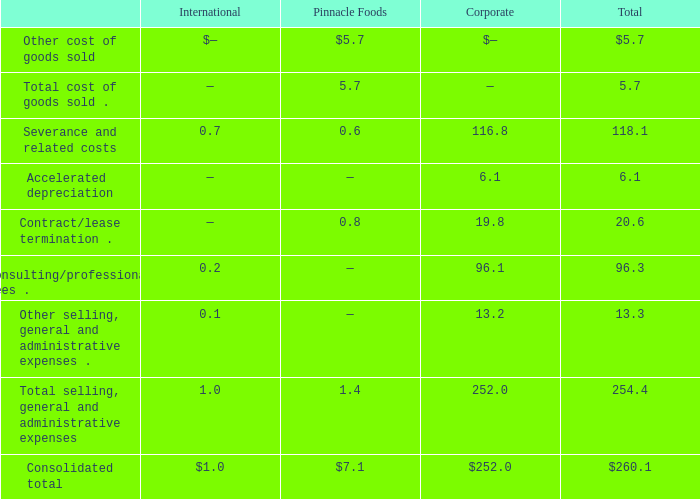Notes to Consolidated Financial Statements - (Continued) Fiscal Years Ended May 26, 2019, May 27, 2018, and May 28, 2017 (columnar dollars in millions except per share amounts) 3. RESTRUCTURING ACTIVITIES
Pinnacle Integration Restructuring Plan
In December 2018, our Board of Directors (the "Board") approved a restructuring and integration plan related to the ongoing integration of the recently acquired operations of Pinnacle (the "Pinnacle Integration Restructuring Plan") for the purpose of achieving significant cost synergies between the companies. We expect to incur material charges for exit and disposal activities under U.S. GAAP. Although we remain unable to make good faith estimates relating to the entire Pinnacle Integration Restructuring Plan, we are reporting on actions initiated through the end of fiscal 2019, including the estimated amounts or range of amounts for each major type of costs expected to be incurred, and the charges that have resulted or will result in cash outflows. We expect to incur up to $360.0 million of operational expenditures ($285.0 million of cash charges and $75.0 million of non-cash charges) as well as $85.0 million of capital expenditures under the Pinnacle Integration Restructuring Plan. We have incurred or expect to incur approximately $260.1 million of charges ($254.0 million of cash charges and $6.1 million of non-cash charges) for actions identified to date under the Pinnacle Integration Restructuring Plan. We expect to incur costs related to the Pinnacle Integration Restructuring Plan over a three-year period.  In December 2018, our Board of Directors (the "Board") approved a restructuring and integration plan related to the ongoing integration of the recently acquired operations of Pinnacle (the "Pinnacle Integration Restructuring Plan") for the purpose of achieving significant cost synergies between the companies. We expect to incur material charges for exit and disposal activities under U.S. GAAP. Although we remain unable to make good faith estimates relating to the entire Pinnacle Integration Restructuring Plan, we are reporting on actions initiated through the end of fiscal 2019, including the estimated amounts or range of amounts for each major type of costs expected to be incurred, and the charges that have resulted or will result in cash outflows. We expect to incur up to $360.0 million of operational expenditures ($285.0 million of cash charges and $75.0 million of non-cash charges) as well as $85.0 million of capital expenditures under the Pinnacle Integration Restructuring Plan. We have incurred or expect to incur approximately $260.1 million of charges ($254.0 million of cash charges and $6.1 million of non-cash charges) for actions identified to date under the Pinnacle Integration Restructuring Plan. We expect to incur costs related to the Pinnacle Integration Restructuring Plan over a three-year period.  In December 2018, our Board of Directors (the "Board") approved a restructuring and integration plan related to the ongoing integration of the recently acquired operations of Pinnacle (the "Pinnacle Integration Restructuring Plan") for the purpose of achieving significant cost synergies between the companies. We expect to incur material charges for exit and disposal activities under U.S. GAAP. Although we remain unable to make good faith estimates relating to the entire Pinnacle Integration Restructuring Plan, we are reporting on actions initiated through the end of fiscal 2019, including the estimated amounts or range of amounts for each major type of costs expected to be incurred, and the charges that have resulted or will result in cash outflows. We expect to incur up to $360.0 million of operational expenditures ($285.0 million of cash charges and $75.0 million of non-cash charges) as well as $85.0 million of capital expenditures under the Pinnacle Integration Restructuring Plan. We have incurred or expect to incur approximately $260.1 million of charges ($254.0 million of cash charges and $6.1 million of non-cash charges) for actions identified to date under the Pinnacle Integration Restructuring Plan. We expect to incur costs related to the Pinnacle Integration Restructuring Plan over a three-year period.
We anticipate that we will recognize the following pre-tax expenses in association with the Pinnacle Integration Restructuring Plan (amounts include charges recognized from plan inception through the end of fiscal 2019):
What did the Board of Directors approve in December 2018?  A restructuring and integration plan related to the ongoing integration of the recently acquired operations of pinnacle (the "pinnacle integration restructuring plan") for the purpose of achieving significant cost synergies between the companies. What are the expected expenditures for both operational and capital under the Pinnacle Integration Restructuring Plan respectively?  $360.0 million, $85.0 million. What are the consolidated total pre-tax expenses in International and Corporate segments, respectively? 
Answer scale should be: million. $1.0, $252.0. Which segment has the highest total selling, general and administrative expenses? 252.0>1.4>1.0
Answer: corporate. What is the ratio of consolidated total pre-tax expenses in Pinnacle Foods to the one in Corporate? 7.1/252.0
Answer: 0.03. What is the proportion of total accelerated depreciation expense and total contract/lease termination expense over total consolidated pre-tax expenses in all segments? (6.1+20.6)/260.1 
Answer: 0.1. 